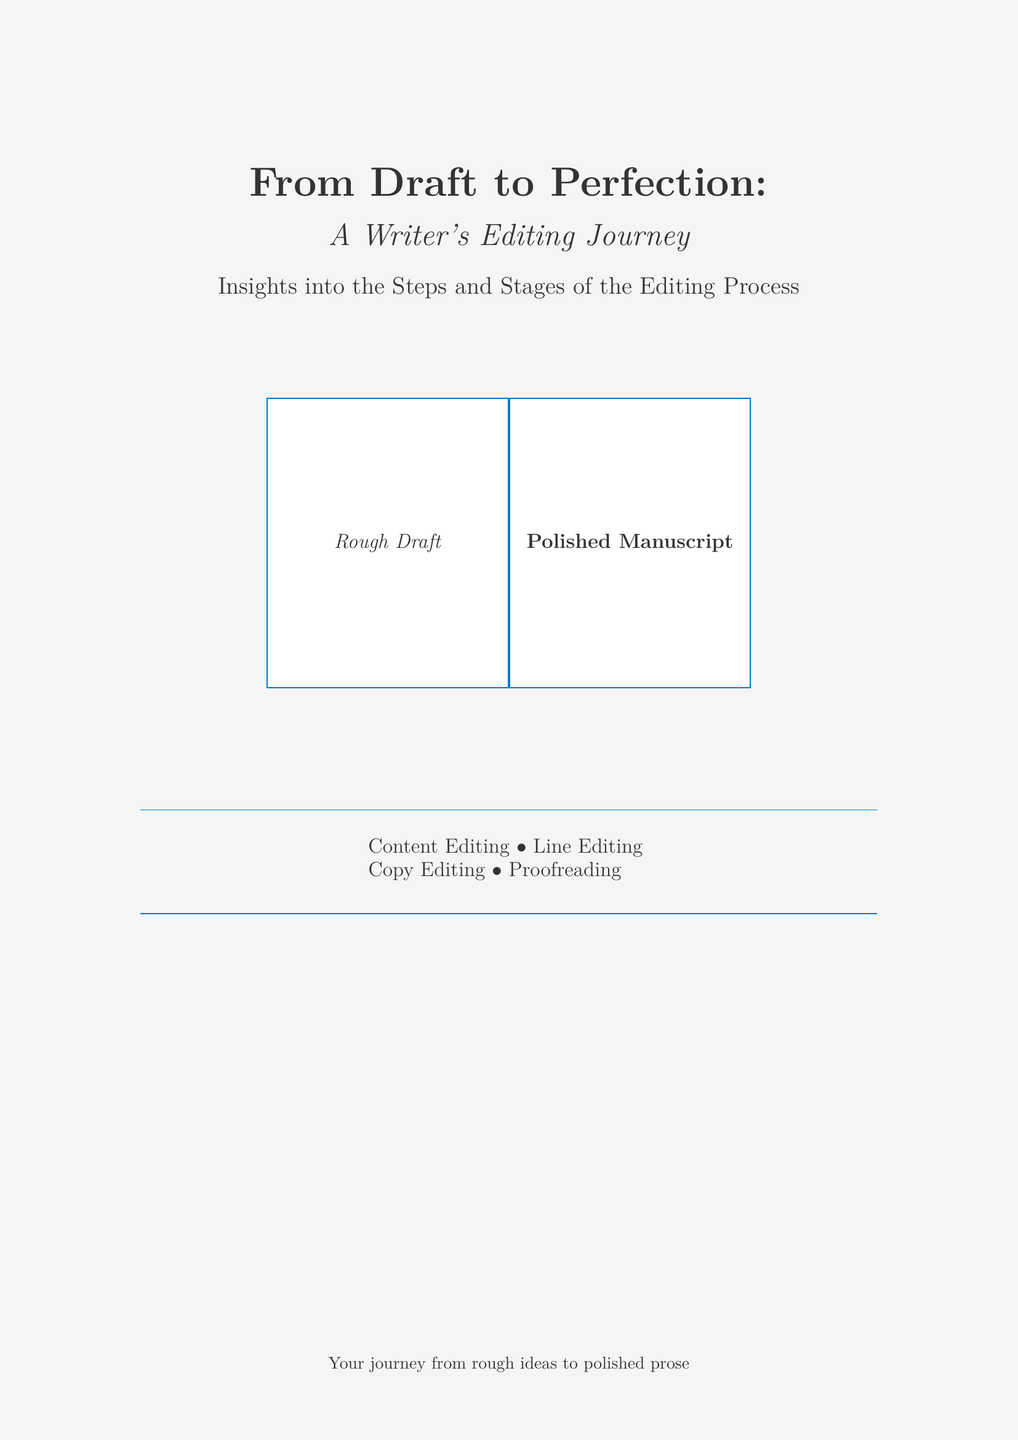What is the title of the book? The title is prominently featured at the top of the document in large font.
Answer: From Draft to Perfection What is the subtitle of the book? The subtitle is presented below the title, providing more context.
Answer: A Writer's Editing Journey What are the four editing types mentioned? The document lists the different editing types in a tabular format towards the bottom.
Answer: Content Editing, Line Editing, Copy Editing, Proofreading What color is used for the highlight? The document specifies the highlight color in the section dividing the content.
Answer: 007ACC How many sections does this book cover visually represent? The visual elements in the document show two distinct sections.
Answer: Two 